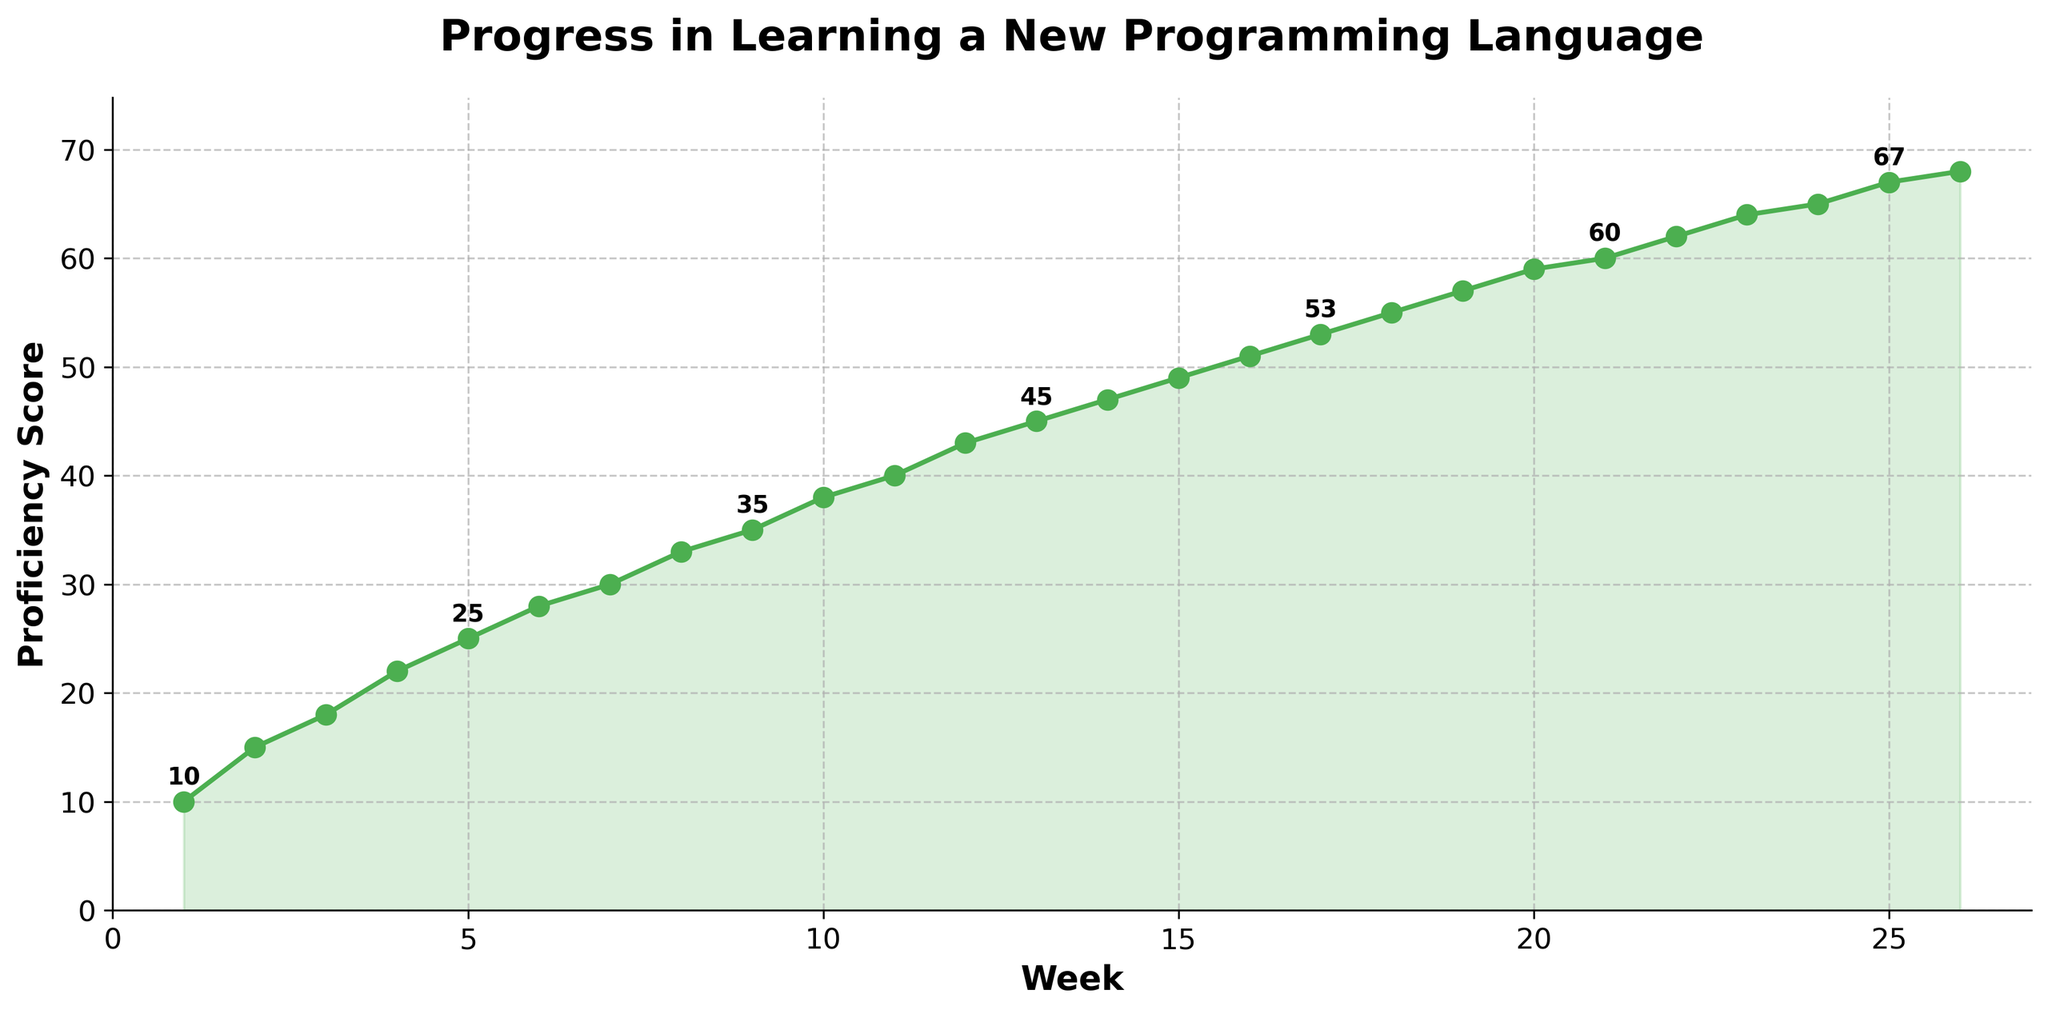What is the proficiency score at Week 10? The line chart shows a marker at each week. To find the proficiency score at Week 10, locate Week 10 along the x-axis and look at the corresponding y-value. The score at Week 10 is marked as 38.
Answer: 38 Which week shows the first instance of a proficiency score above 60? Locate the point where the proficiency score first crosses the 60 mark on the y-axis. This occurs between Weeks 20 and 22. By checking the data points, the first instance occurs at Week 21 with a score of 60.
Answer: Week 21 What is the overall trend in the proficiency scores over the 6-month period? To determine the overall trend, observe the direction in which the line progresses from Week 1 to Week 26. The line consistently moves upwards, indicating a positive increasing trend in proficiency scores every week.
Answer: Increasing trend By how many points did the proficiency score increase between Week 1 and Week 26? To find the increase in proficiency score, subtract the score at Week 1 from the score at Week 26. The proficiency score at Week 1 is 10, and at Week 26 it is 68. So, 68 - 10 = 58.
Answer: 58 Compare the proficiency scores at Week 15 and Week 20. Which week had a higher score and by how much? Check the proficiency scores for Week 15 and Week 20 from the chart. Week 15 has a score of 49, and Week 20 has a score of 59. Week 20's score is higher. The difference is 59 - 49 = 10.
Answer: Week 20 by 10 At which week did the proficiency score reach 50 points? Scan through the chart to find the point where the proficiency score reaches 50. This occurs between Weeks 16 and 17. So, around Week 16, the proficiency score first surpasses 50.
Answer: Week 16 Is there any week where the increase in proficiency score is less than the previous week? Observe the curve's steepness at each week. The line grows consistently, with no visible dips or plateaus, indicating steady improvement each week. Therefore, no week exhibits a slower rate of increase compared to the previous week.
Answer: No What is the average proficiency score during the 6-month period? Sum all proficiency scores and divide by the number of weeks. The sum of scores is 1245, divided by 26 weeks, gives an average score of approximately 47.88.
Answer: 47.88 